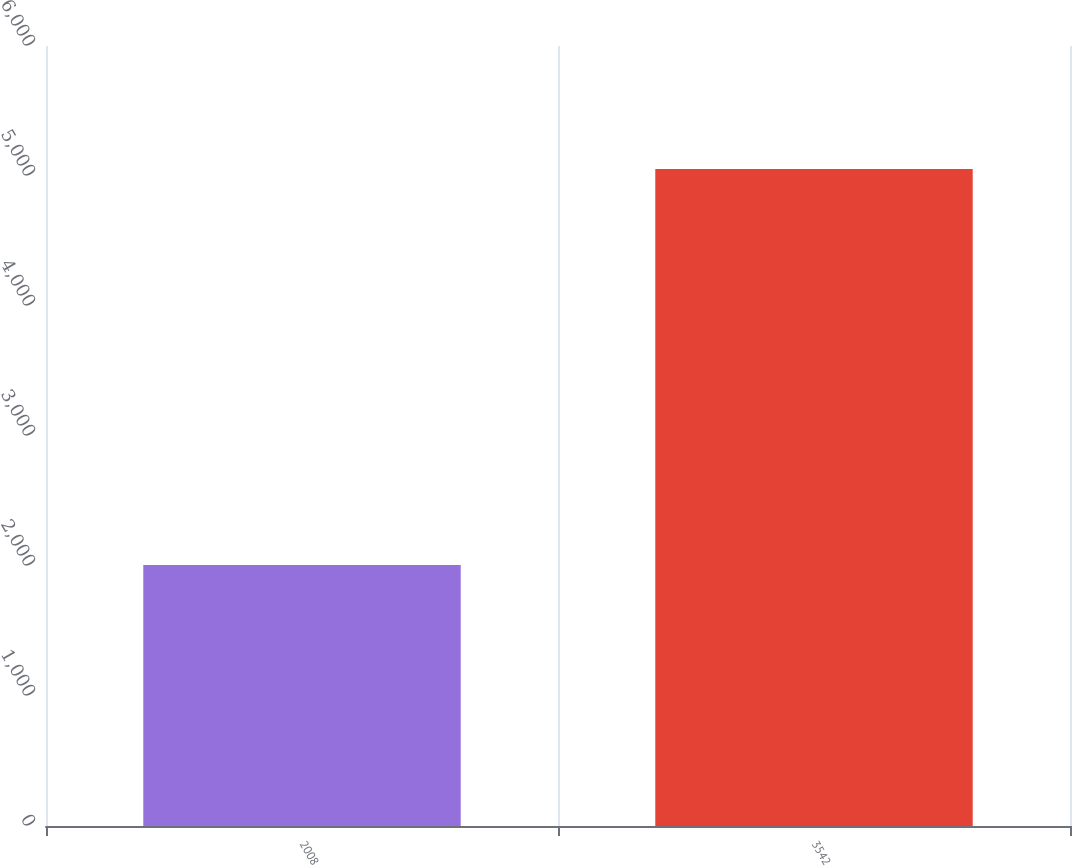Convert chart. <chart><loc_0><loc_0><loc_500><loc_500><bar_chart><fcel>2008<fcel>3542<nl><fcel>2007<fcel>5054<nl></chart> 